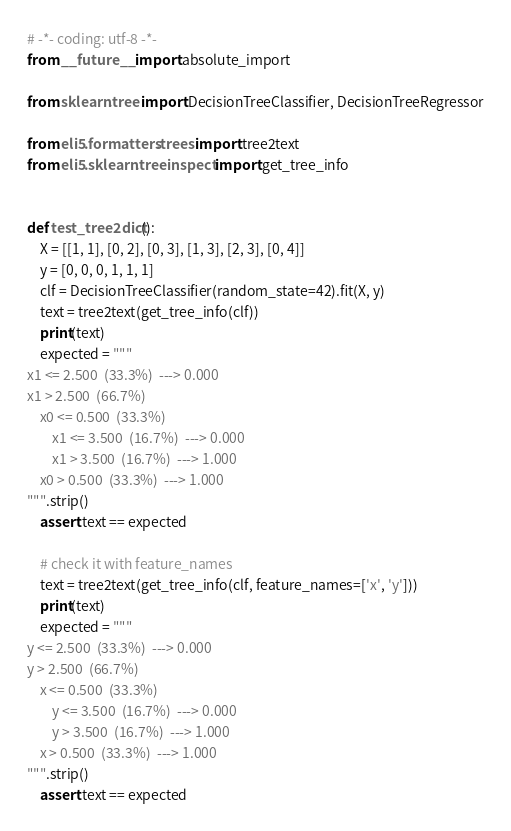Convert code to text. <code><loc_0><loc_0><loc_500><loc_500><_Python_># -*- coding: utf-8 -*-
from __future__ import absolute_import

from sklearn.tree import DecisionTreeClassifier, DecisionTreeRegressor

from eli5.formatters.trees import tree2text
from eli5.sklearn.treeinspect import get_tree_info


def test_tree2dict():
    X = [[1, 1], [0, 2], [0, 3], [1, 3], [2, 3], [0, 4]]
    y = [0, 0, 0, 1, 1, 1]
    clf = DecisionTreeClassifier(random_state=42).fit(X, y)
    text = tree2text(get_tree_info(clf))
    print(text)
    expected = """
x1 <= 2.500  (33.3%)  ---> 0.000
x1 > 2.500  (66.7%)
    x0 <= 0.500  (33.3%)
        x1 <= 3.500  (16.7%)  ---> 0.000
        x1 > 3.500  (16.7%)  ---> 1.000
    x0 > 0.500  (33.3%)  ---> 1.000
""".strip()
    assert text == expected

    # check it with feature_names
    text = tree2text(get_tree_info(clf, feature_names=['x', 'y']))
    print(text)
    expected = """
y <= 2.500  (33.3%)  ---> 0.000
y > 2.500  (66.7%)
    x <= 0.500  (33.3%)
        y <= 3.500  (16.7%)  ---> 0.000
        y > 3.500  (16.7%)  ---> 1.000
    x > 0.500  (33.3%)  ---> 1.000
""".strip()
    assert text == expected

</code> 